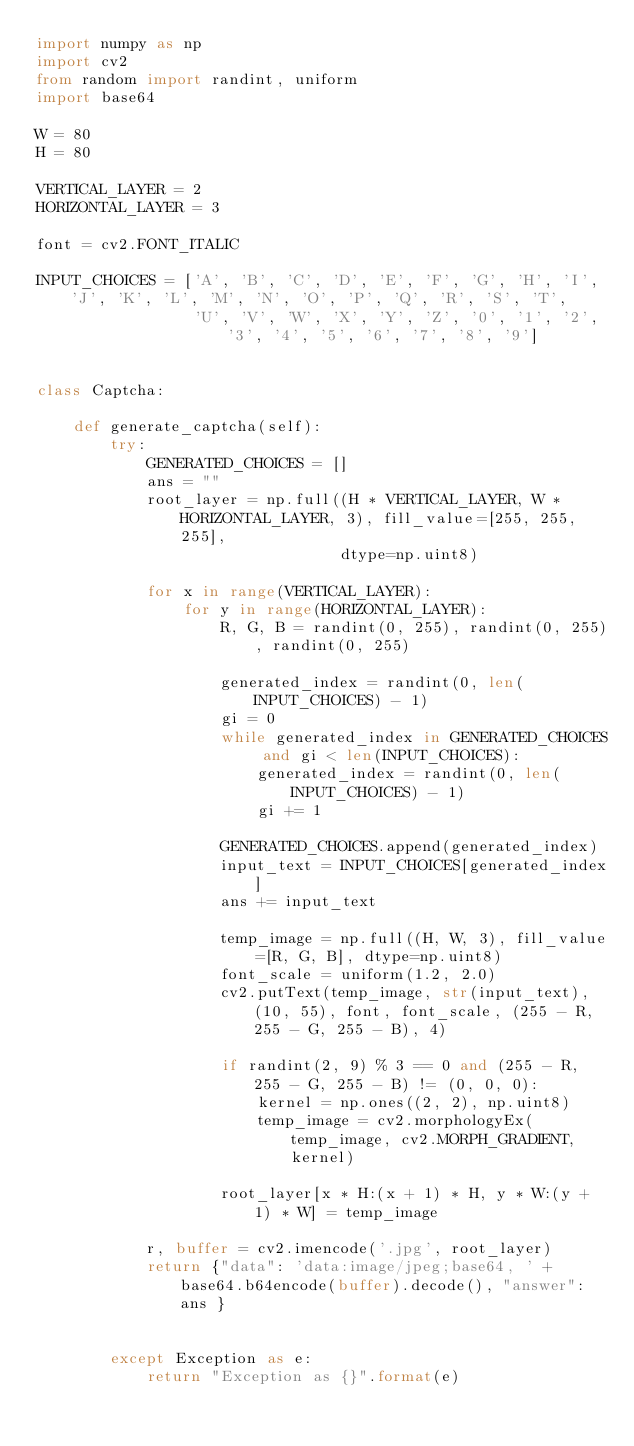<code> <loc_0><loc_0><loc_500><loc_500><_Python_>import numpy as np
import cv2
from random import randint, uniform
import base64

W = 80
H = 80

VERTICAL_LAYER = 2
HORIZONTAL_LAYER = 3

font = cv2.FONT_ITALIC

INPUT_CHOICES = ['A', 'B', 'C', 'D', 'E', 'F', 'G', 'H', 'I', 'J', 'K', 'L', 'M', 'N', 'O', 'P', 'Q', 'R', 'S', 'T',
                 'U', 'V', 'W', 'X', 'Y', 'Z', '0', '1', '2', '3', '4', '5', '6', '7', '8', '9']


class Captcha:

    def generate_captcha(self):
        try:
            GENERATED_CHOICES = []
            ans = ""
            root_layer = np.full((H * VERTICAL_LAYER, W * HORIZONTAL_LAYER, 3), fill_value=[255, 255, 255],
                                 dtype=np.uint8)

            for x in range(VERTICAL_LAYER):
                for y in range(HORIZONTAL_LAYER):
                    R, G, B = randint(0, 255), randint(0, 255), randint(0, 255)

                    generated_index = randint(0, len(INPUT_CHOICES) - 1)
                    gi = 0
                    while generated_index in GENERATED_CHOICES and gi < len(INPUT_CHOICES):
                        generated_index = randint(0, len(INPUT_CHOICES) - 1)
                        gi += 1

                    GENERATED_CHOICES.append(generated_index)
                    input_text = INPUT_CHOICES[generated_index]
                    ans += input_text

                    temp_image = np.full((H, W, 3), fill_value=[R, G, B], dtype=np.uint8)
                    font_scale = uniform(1.2, 2.0)
                    cv2.putText(temp_image, str(input_text), (10, 55), font, font_scale, (255 - R, 255 - G, 255 - B), 4)

                    if randint(2, 9) % 3 == 0 and (255 - R, 255 - G, 255 - B) != (0, 0, 0):
                        kernel = np.ones((2, 2), np.uint8)
                        temp_image = cv2.morphologyEx(temp_image, cv2.MORPH_GRADIENT, kernel)

                    root_layer[x * H:(x + 1) * H, y * W:(y + 1) * W] = temp_image

            r, buffer = cv2.imencode('.jpg', root_layer)
            return {"data": 'data:image/jpeg;base64, ' + base64.b64encode(buffer).decode(), "answer": ans }


        except Exception as e:
            return "Exception as {}".format(e)
</code> 